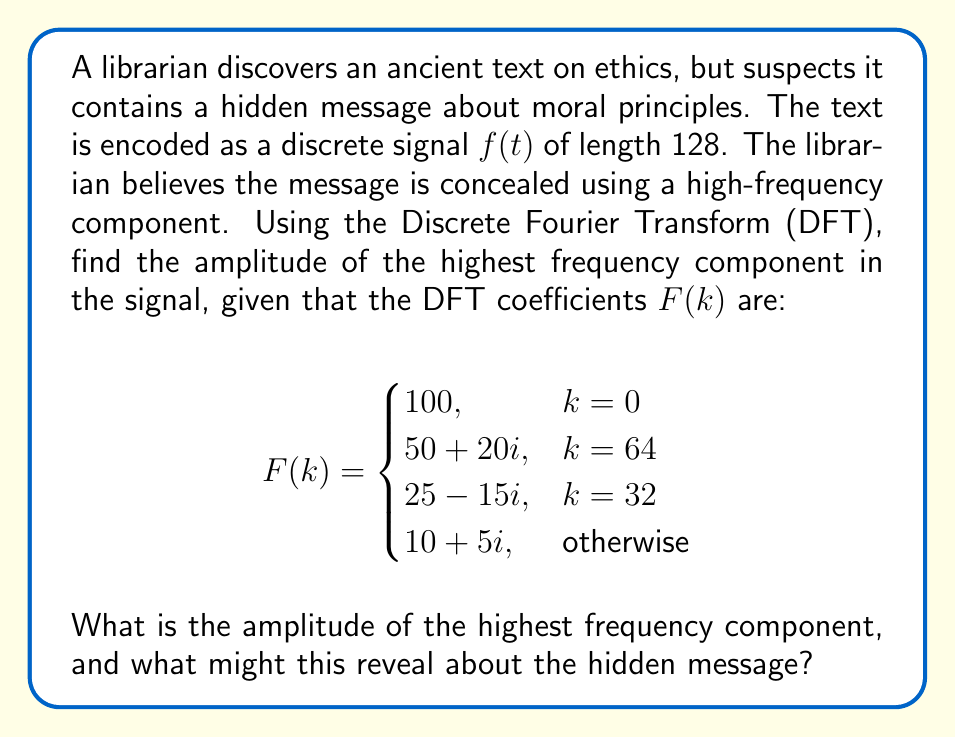Solve this math problem. To solve this problem, we need to follow these steps:

1) Recall that for a discrete signal of length N, the highest frequency component corresponds to k = N/2 in the DFT.

2) In this case, N = 128, so the highest frequency component is at k = 64.

3) The DFT coefficient at k = 64 is given as F(64) = 50 + 20i.

4) To find the amplitude of this component, we need to calculate the magnitude of this complex number:

   $$|F(64)| = \sqrt{(\text{Re}(F(64)))^2 + (\text{Im}(F(64)))^2}$$

   $$|F(64)| = \sqrt{50^2 + 20^2}$$

5) Calculating:
   
   $$|F(64)| = \sqrt{2500 + 400} = \sqrt{2900} = 10\sqrt{29} \approx 53.85$$

6) This amplitude is significantly larger than the "otherwise" case (which has an amplitude of $\sqrt{10^2 + 5^2} = 5\sqrt{5} \approx 11.18$), indicating a strong high-frequency component.

7) In the context of the problem, this suggests that the hidden message is indeed encoded in the high-frequency component of the signal. The librarian's suspicion was correct.

8) From an ethical standpoint, this could imply that the hidden message contains important moral principles or ethical guidelines that were intentionally concealed, perhaps to protect them from censorship or to ensure they were only discovered by those diligent enough to look for them.
Answer: The amplitude of the highest frequency component is $10\sqrt{29} \approx 53.85$. This relatively large amplitude suggests that the hidden message is indeed encoded in the high-frequency component, potentially containing important ethical or moral principles. 